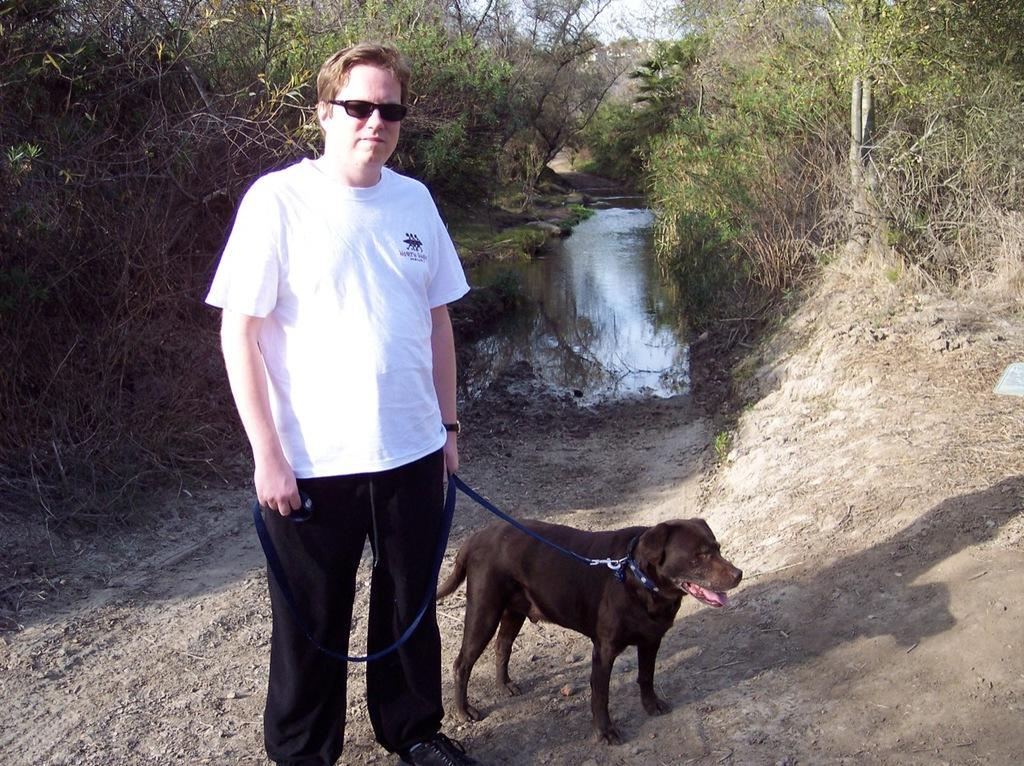What is the man doing on the left side of the image? The man is standing on the left side of the image. What is the man holding in the image? The man is holding a dog in the image. Where is the dog located in the image? The dog is on the right side of the image. What can be seen in the background of the image? There are trees and a lake in the background of the image. What type of beast is the man riding in the image? There is no beast present in the image, and the man is not riding anything. What is the base of the dog made of in the image? The dog is not on a base in the image; it is being held by the man. 